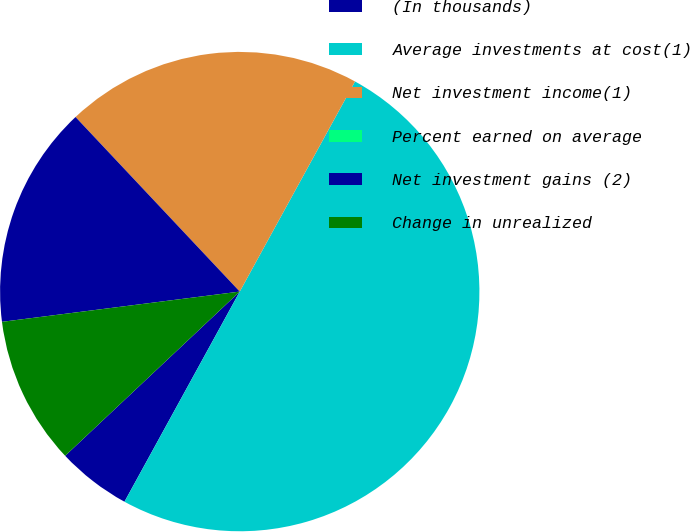Convert chart to OTSL. <chart><loc_0><loc_0><loc_500><loc_500><pie_chart><fcel>(In thousands)<fcel>Average investments at cost(1)<fcel>Net investment income(1)<fcel>Percent earned on average<fcel>Net investment gains (2)<fcel>Change in unrealized<nl><fcel>5.0%<fcel>50.0%<fcel>20.0%<fcel>0.0%<fcel>15.0%<fcel>10.0%<nl></chart> 